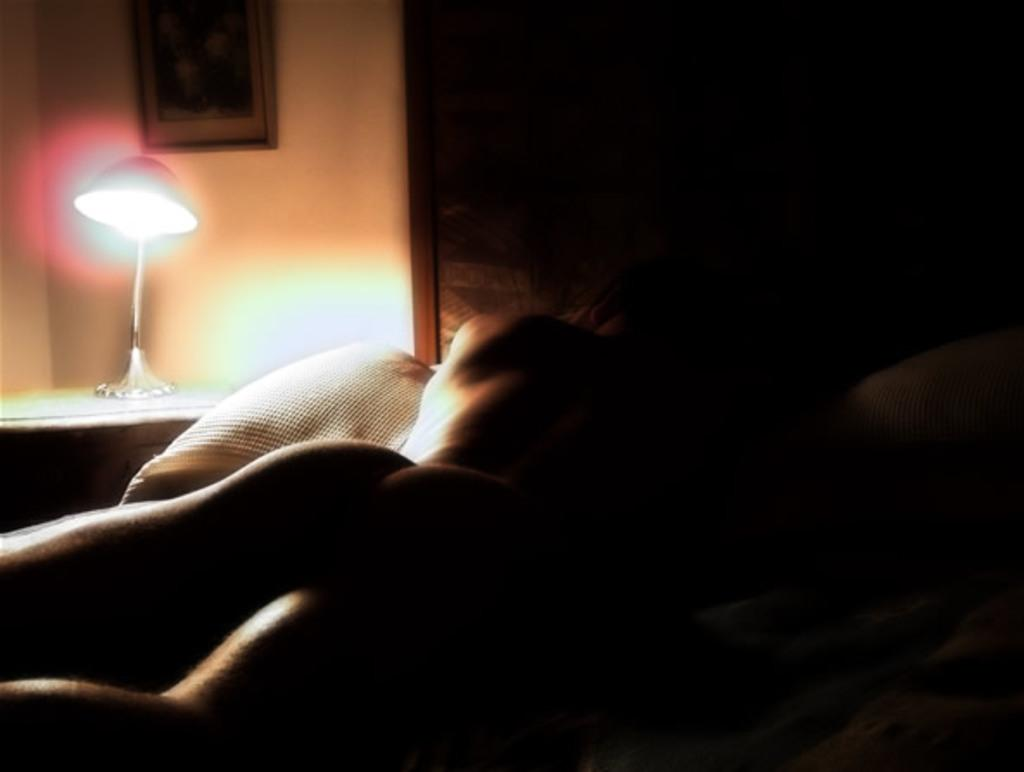What is the main subject of the image? There is a naked person laying on a bed in the image. What object can be seen on a table in the image? There is a lamp on a table in the image. What type of decoration is present on the wall in the image? There is a photograph on the wall in the image. How many circles can be seen on the table in the image? There are no circles visible on the table in the image. What type of police presence is depicted in the image? There is no police presence depicted in the image. 